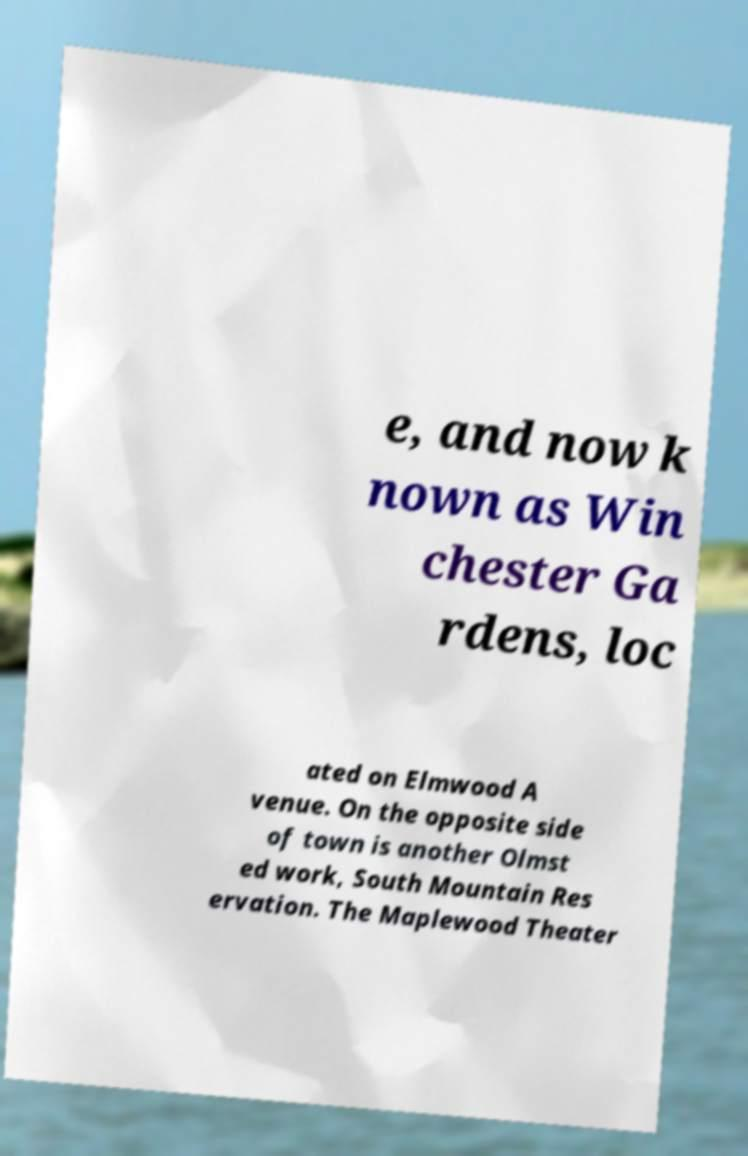Could you assist in decoding the text presented in this image and type it out clearly? e, and now k nown as Win chester Ga rdens, loc ated on Elmwood A venue. On the opposite side of town is another Olmst ed work, South Mountain Res ervation. The Maplewood Theater 